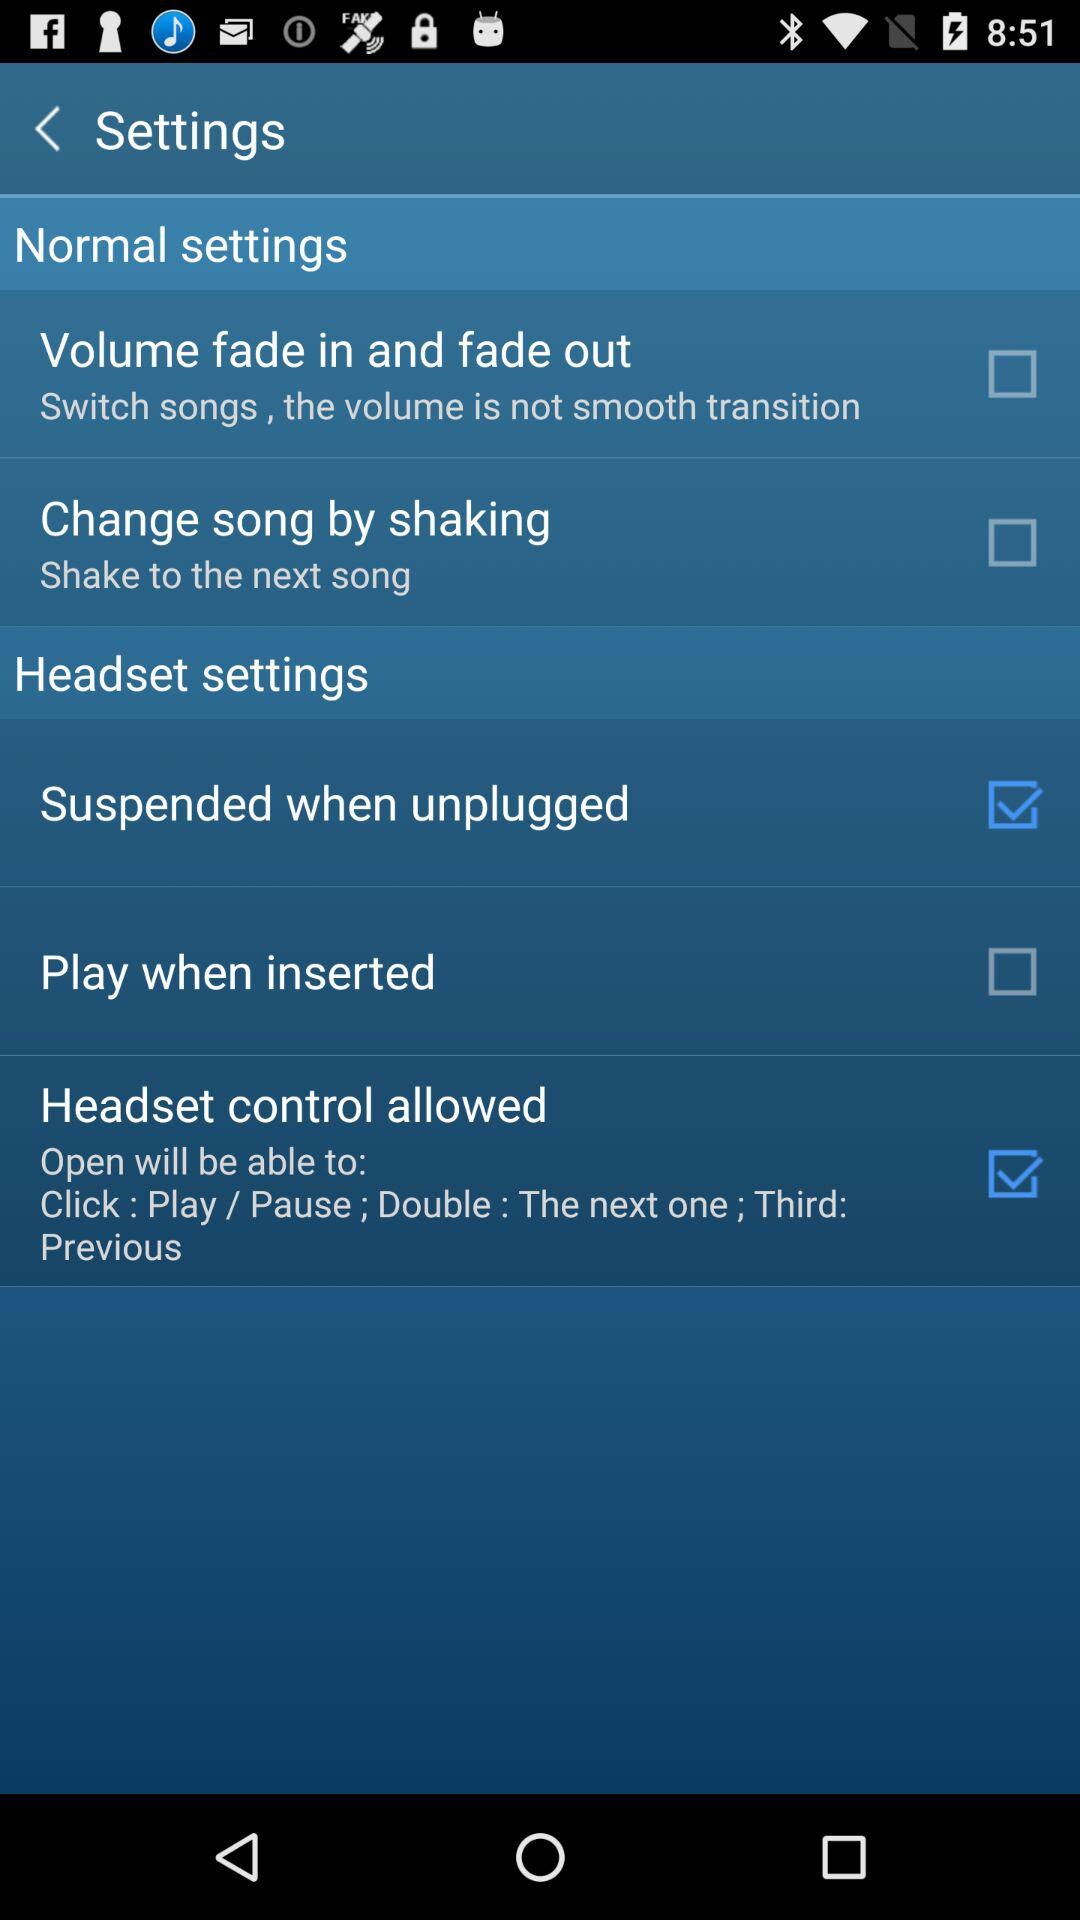How many headset settings are there?
Answer the question using a single word or phrase. 3 